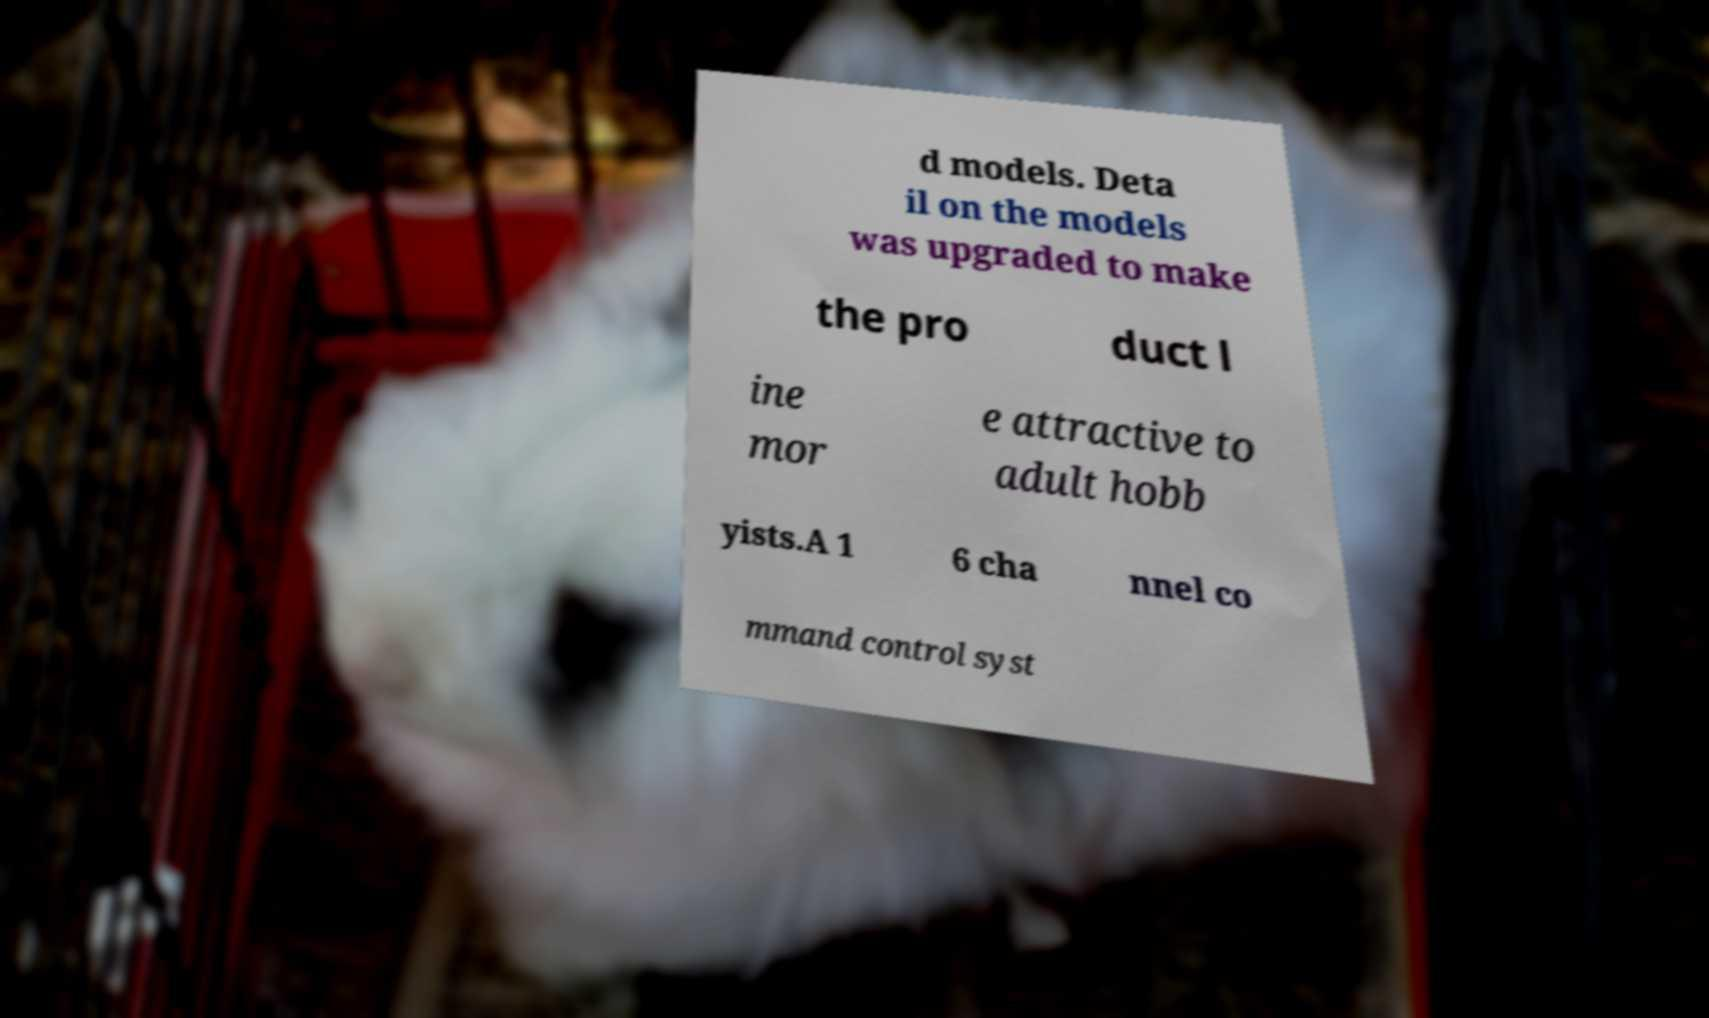What messages or text are displayed in this image? I need them in a readable, typed format. d models. Deta il on the models was upgraded to make the pro duct l ine mor e attractive to adult hobb yists.A 1 6 cha nnel co mmand control syst 